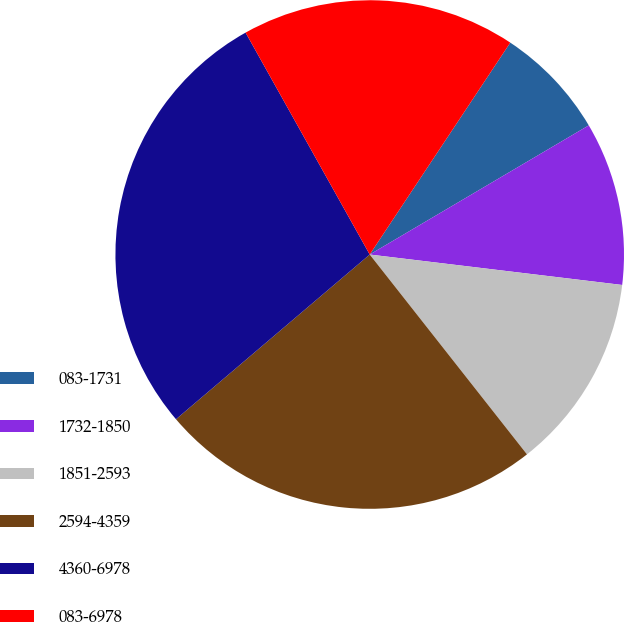<chart> <loc_0><loc_0><loc_500><loc_500><pie_chart><fcel>083-1731<fcel>1732-1850<fcel>1851-2593<fcel>2594-4359<fcel>4360-6978<fcel>083-6978<nl><fcel>7.2%<fcel>10.39%<fcel>12.48%<fcel>24.4%<fcel>28.1%<fcel>17.44%<nl></chart> 